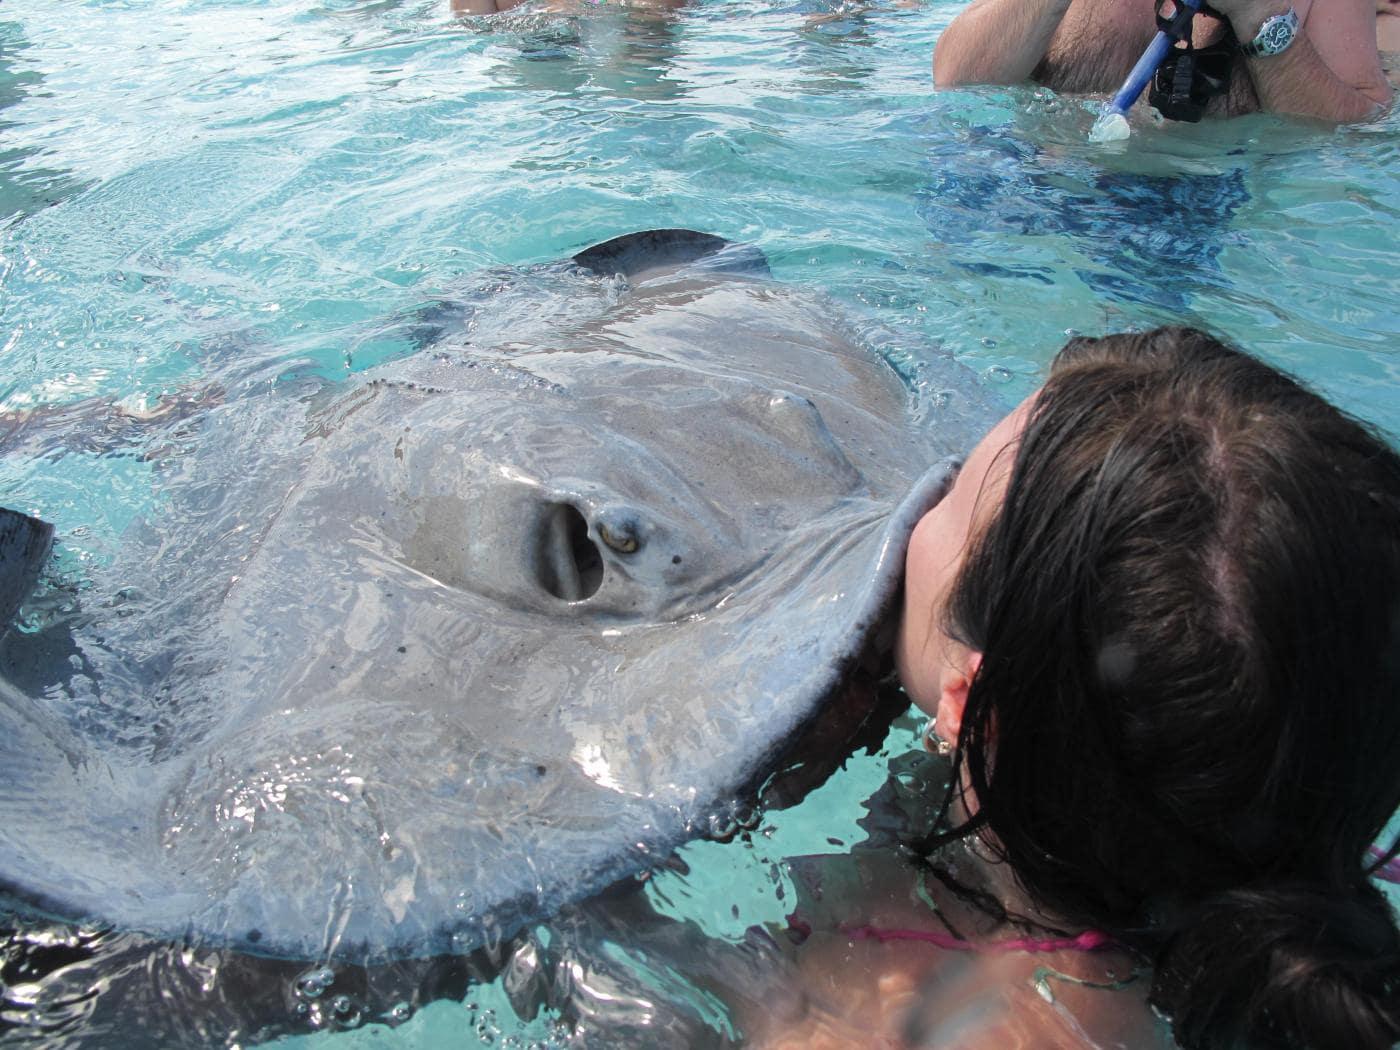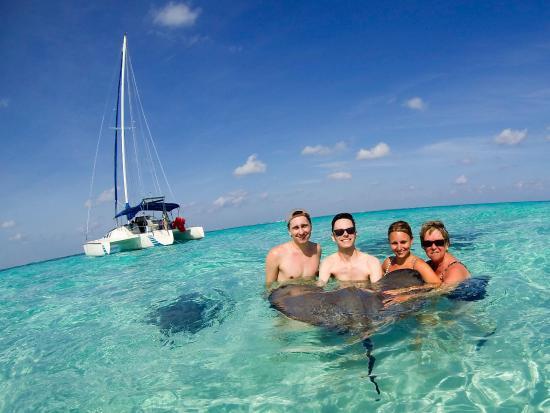The first image is the image on the left, the second image is the image on the right. Given the left and right images, does the statement "Left image shows one brown-haired girl interacting with a large light gray stingray." hold true? Answer yes or no. Yes. The first image is the image on the left, the second image is the image on the right. Examine the images to the left and right. Is the description "A female in the image on the left is standing in the water with a ray." accurate? Answer yes or no. Yes. 